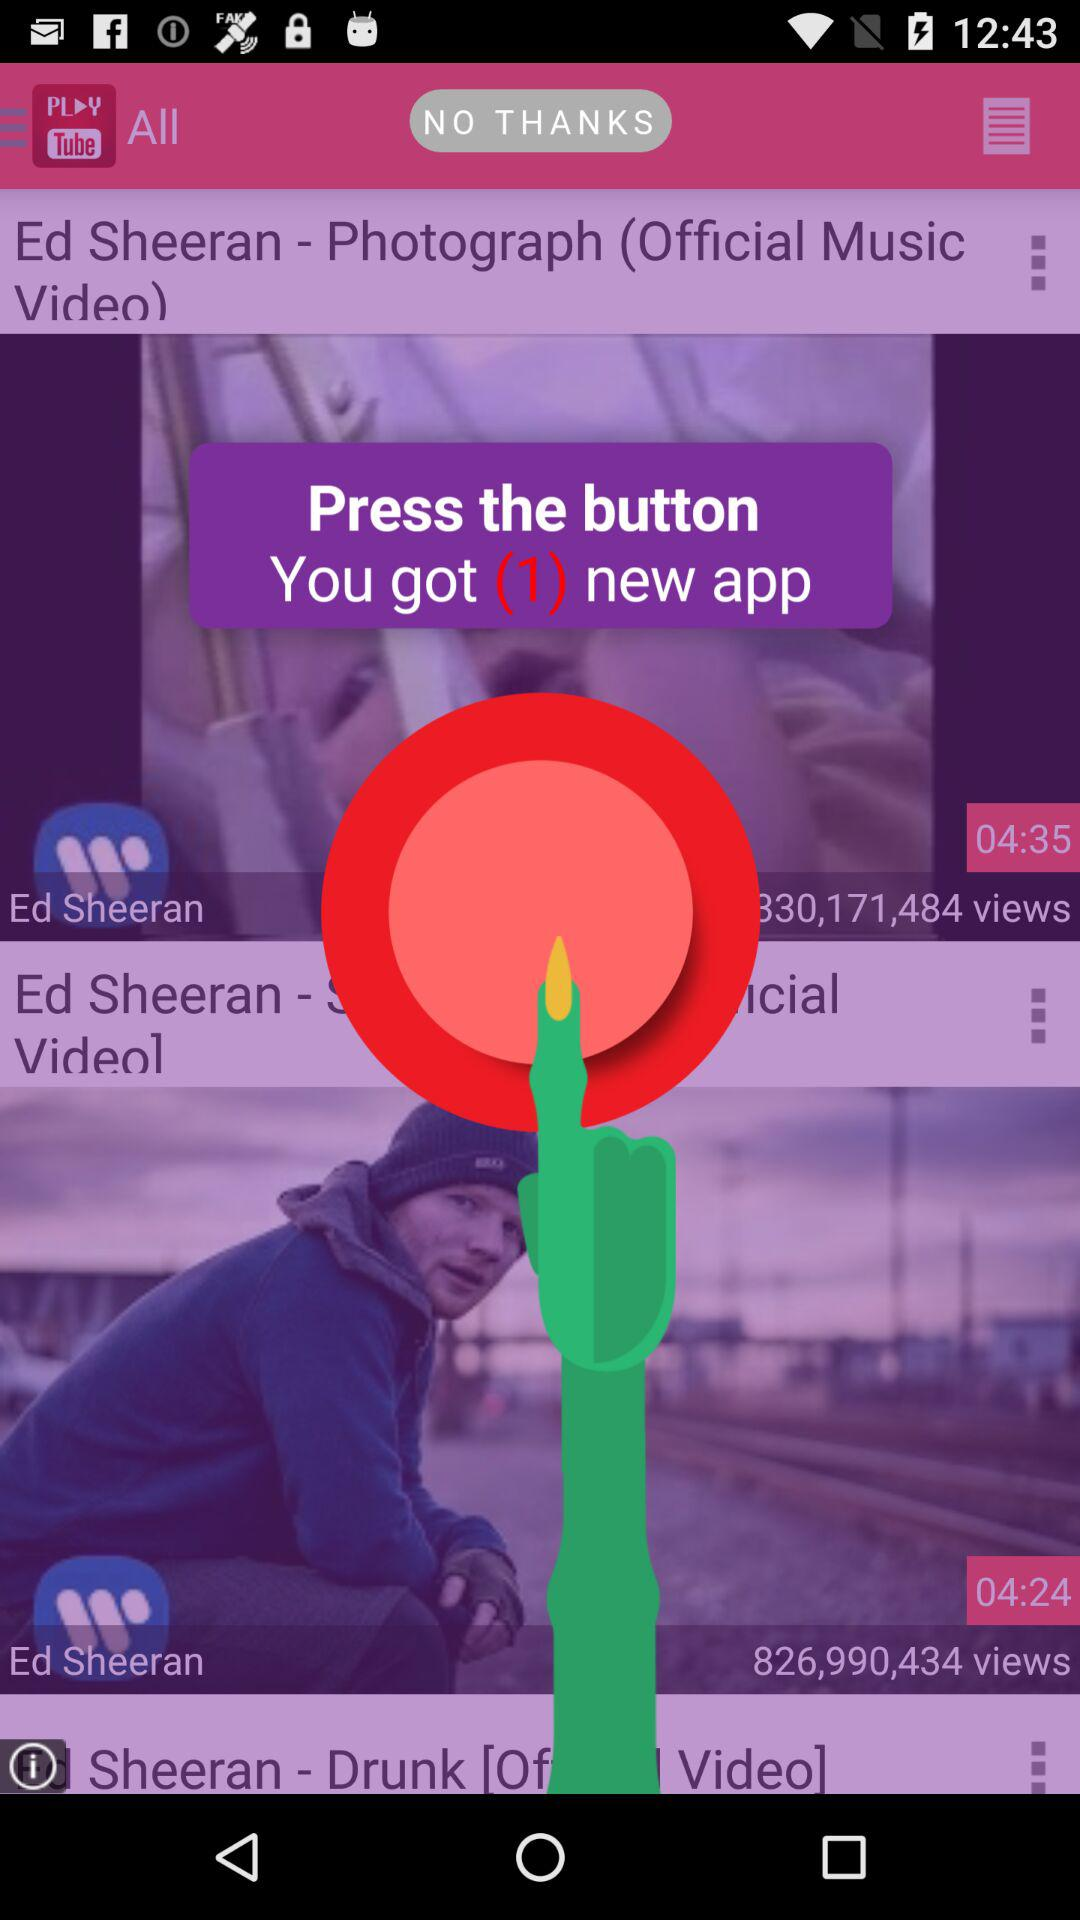How many new applications are there? There is 1 new application. 